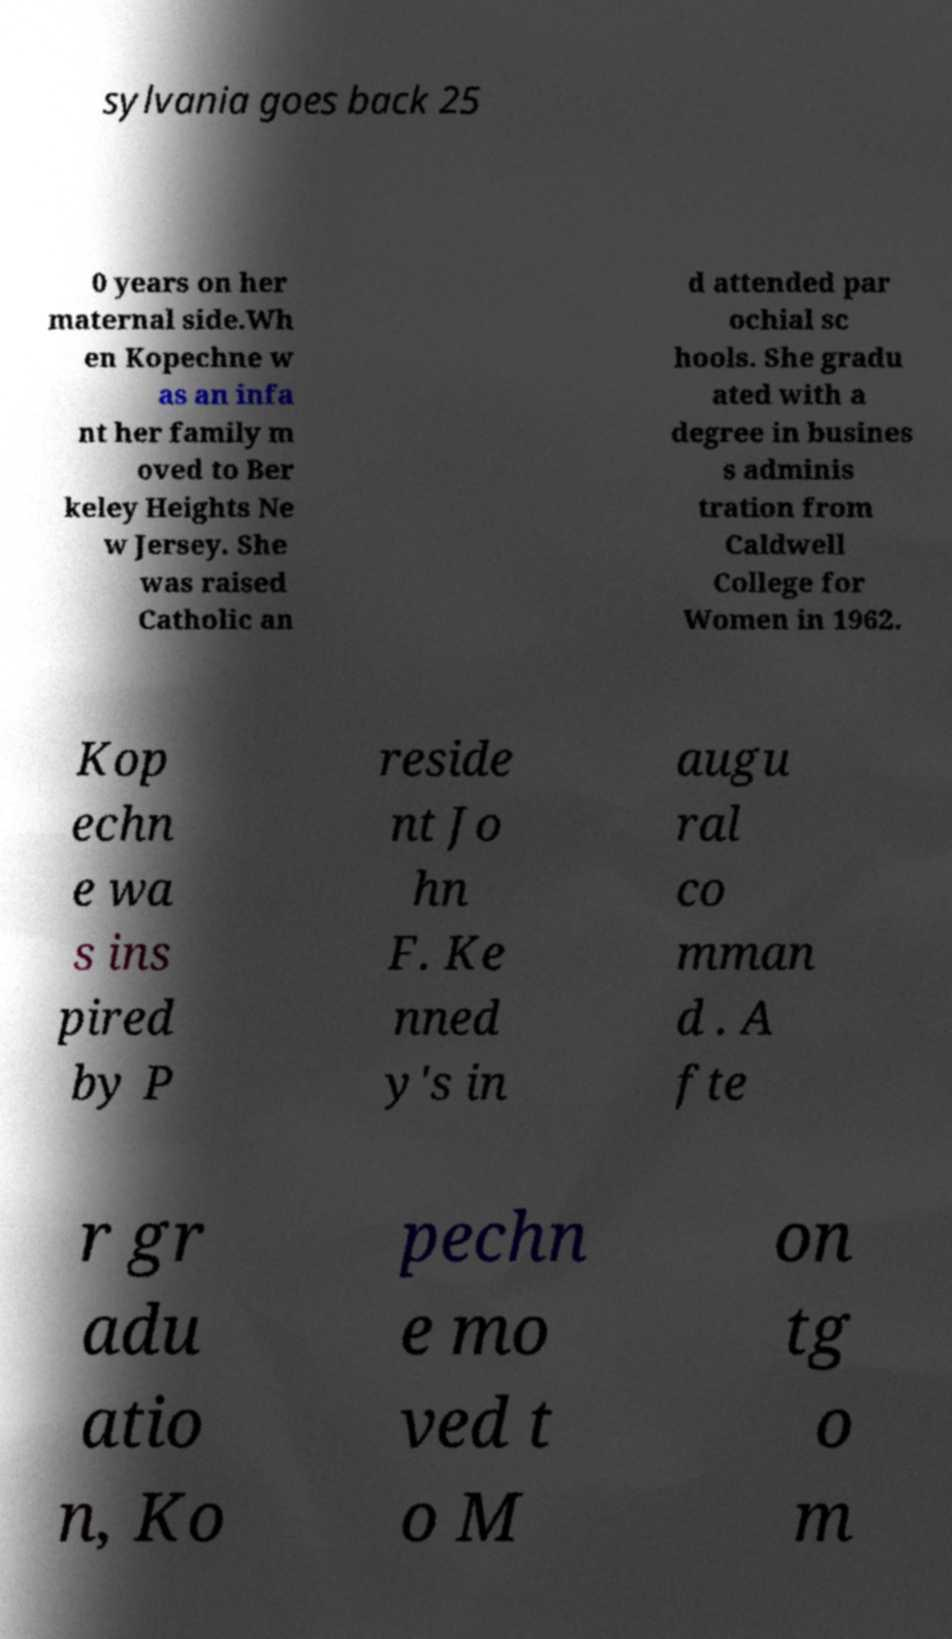Can you read and provide the text displayed in the image?This photo seems to have some interesting text. Can you extract and type it out for me? sylvania goes back 25 0 years on her maternal side.Wh en Kopechne w as an infa nt her family m oved to Ber keley Heights Ne w Jersey. She was raised Catholic an d attended par ochial sc hools. She gradu ated with a degree in busines s adminis tration from Caldwell College for Women in 1962. Kop echn e wa s ins pired by P reside nt Jo hn F. Ke nned y's in augu ral co mman d . A fte r gr adu atio n, Ko pechn e mo ved t o M on tg o m 